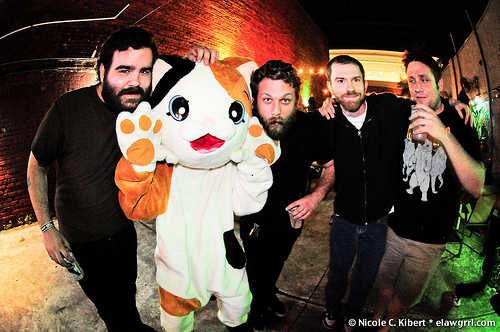<image>
Is the man to the left of the man? Yes. From this viewpoint, the man is positioned to the left side relative to the man. 